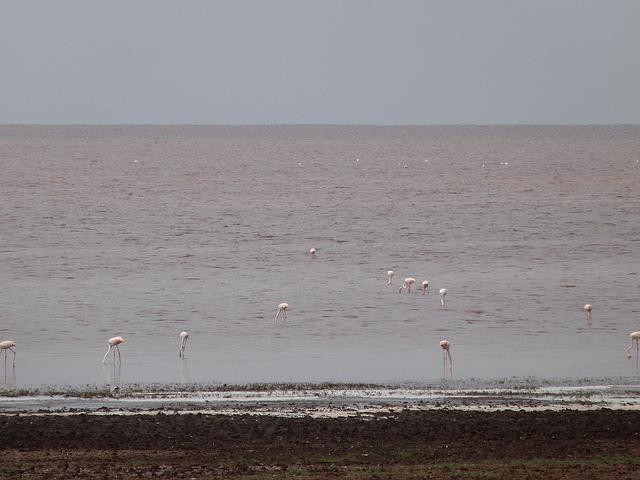What color will these birds become?
From the following set of four choices, select the accurate answer to respond to the question.
Options: White, bright pink, black, green. Bright pink. 